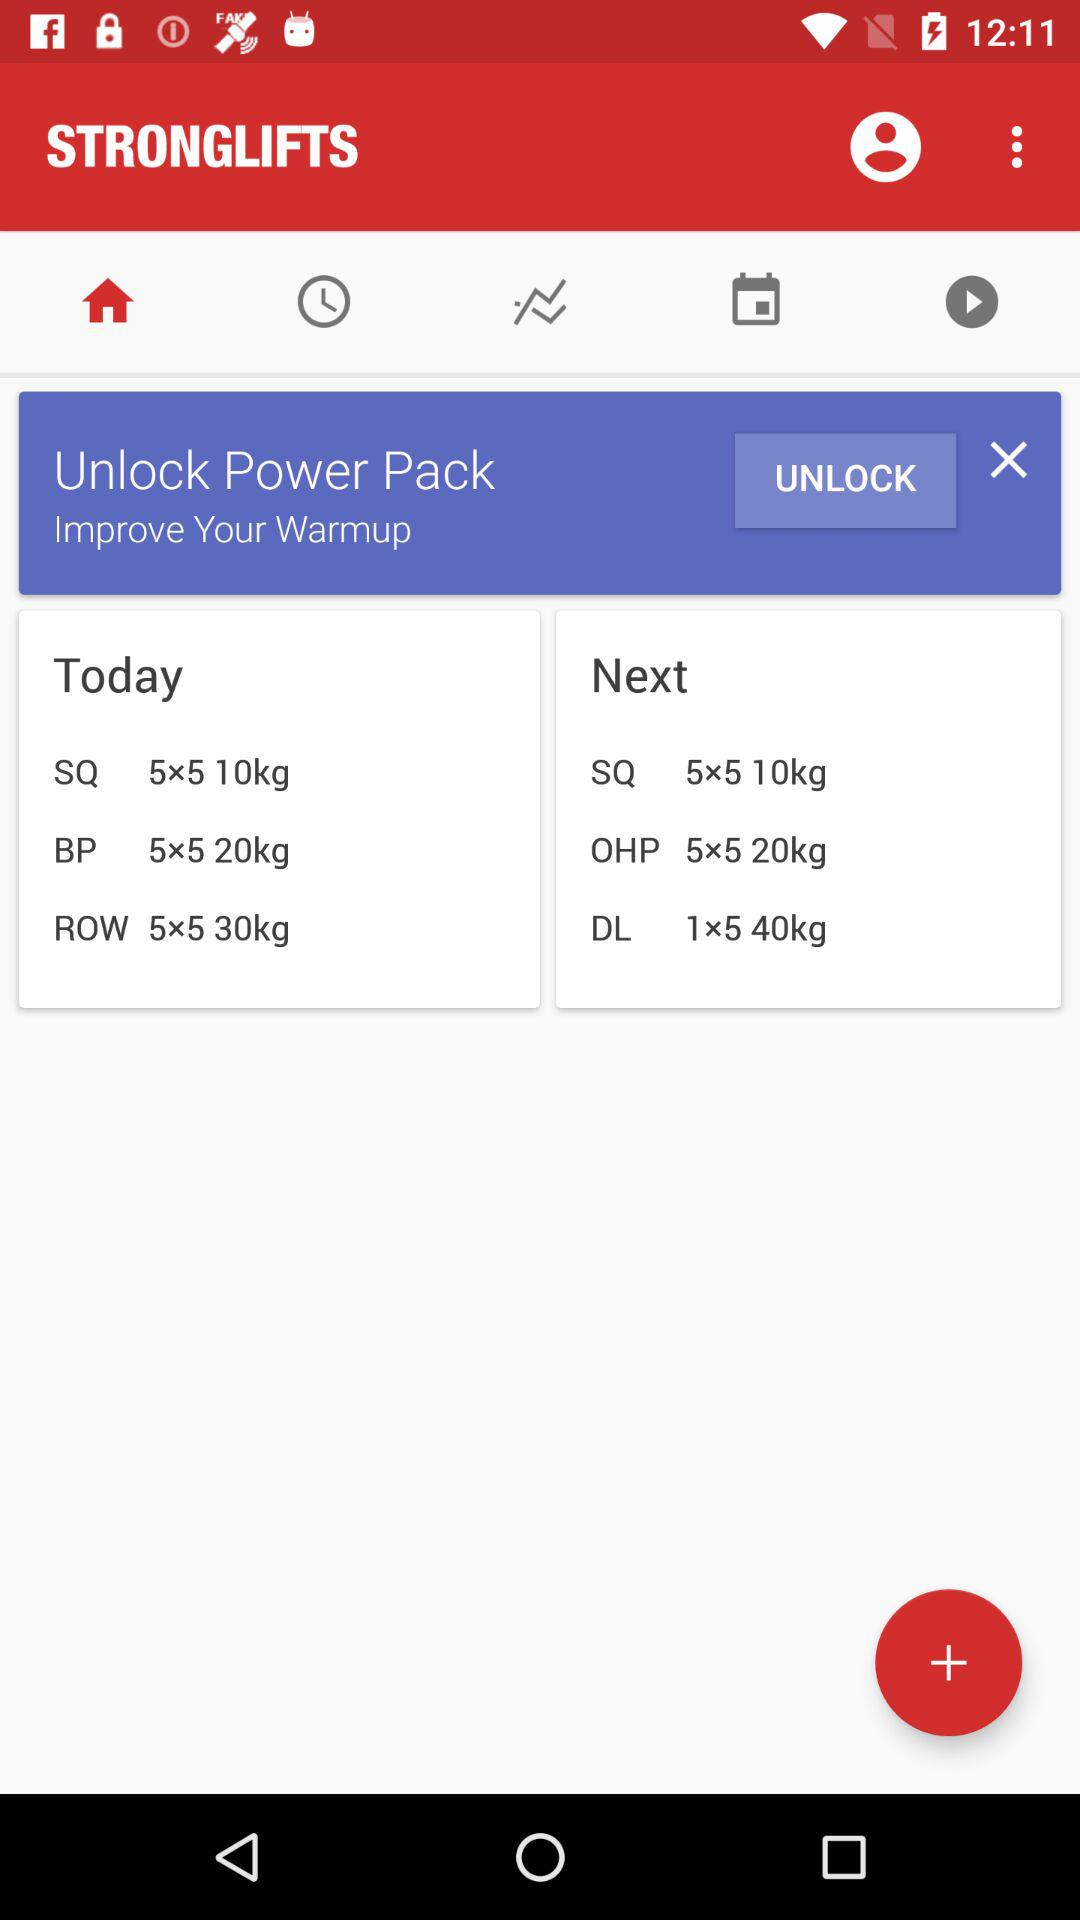What is the profile name?
When the provided information is insufficient, respond with <no answer>. <no answer> 